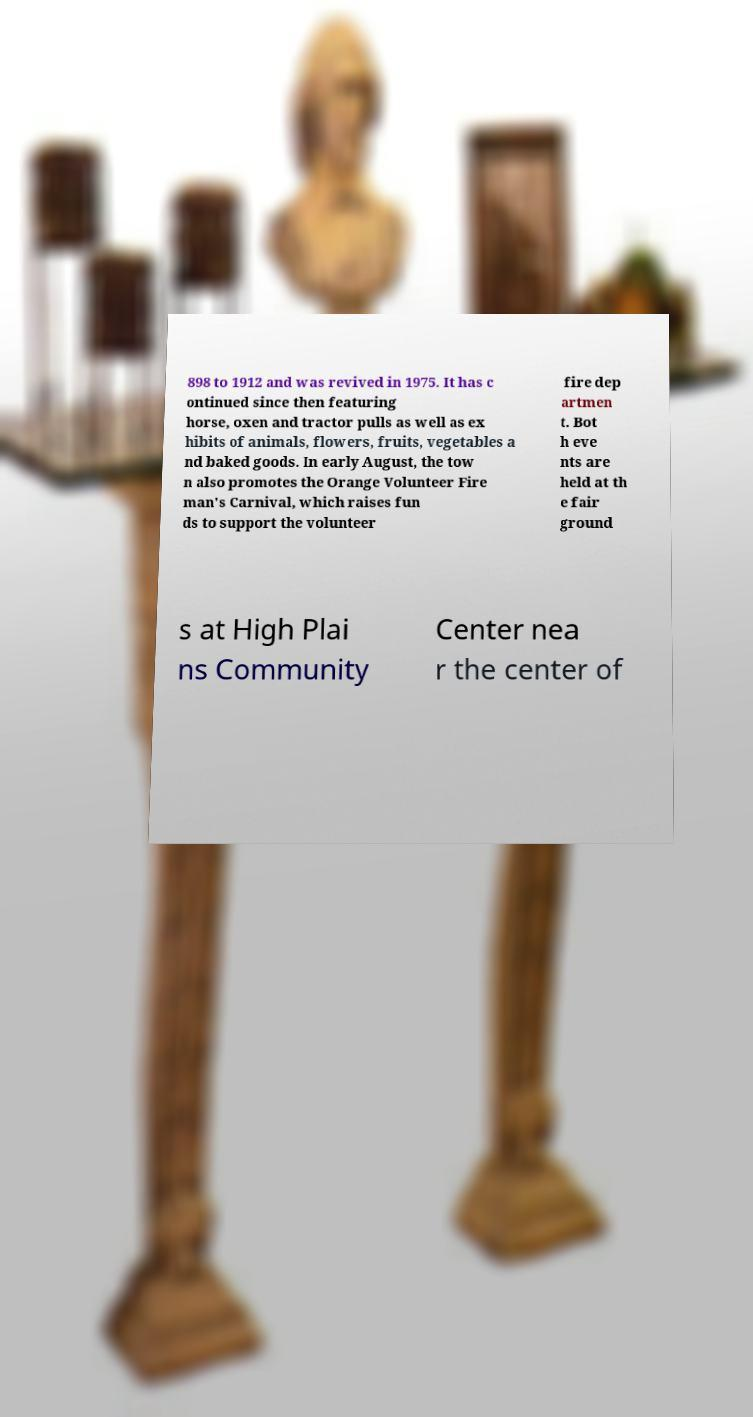Could you assist in decoding the text presented in this image and type it out clearly? 898 to 1912 and was revived in 1975. It has c ontinued since then featuring horse, oxen and tractor pulls as well as ex hibits of animals, flowers, fruits, vegetables a nd baked goods. In early August, the tow n also promotes the Orange Volunteer Fire man's Carnival, which raises fun ds to support the volunteer fire dep artmen t. Bot h eve nts are held at th e fair ground s at High Plai ns Community Center nea r the center of 